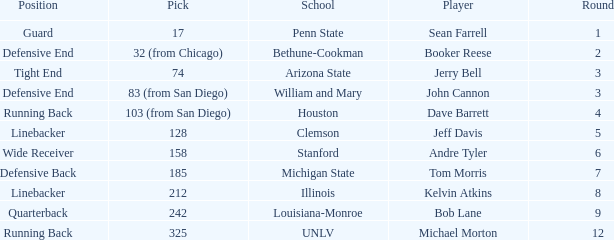Write the full table. {'header': ['Position', 'Pick', 'School', 'Player', 'Round'], 'rows': [['Guard', '17', 'Penn State', 'Sean Farrell', '1'], ['Defensive End', '32 (from Chicago)', 'Bethune-Cookman', 'Booker Reese', '2'], ['Tight End', '74', 'Arizona State', 'Jerry Bell', '3'], ['Defensive End', '83 (from San Diego)', 'William and Mary', 'John Cannon', '3'], ['Running Back', '103 (from San Diego)', 'Houston', 'Dave Barrett', '4'], ['Linebacker', '128', 'Clemson', 'Jeff Davis', '5'], ['Wide Receiver', '158', 'Stanford', 'Andre Tyler', '6'], ['Defensive Back', '185', 'Michigan State', 'Tom Morris', '7'], ['Linebacker', '212', 'Illinois', 'Kelvin Atkins', '8'], ['Quarterback', '242', 'Louisiana-Monroe', 'Bob Lane', '9'], ['Running Back', '325', 'UNLV', 'Michael Morton', '12']]} At which school can a quarterback be found? Louisiana-Monroe. 